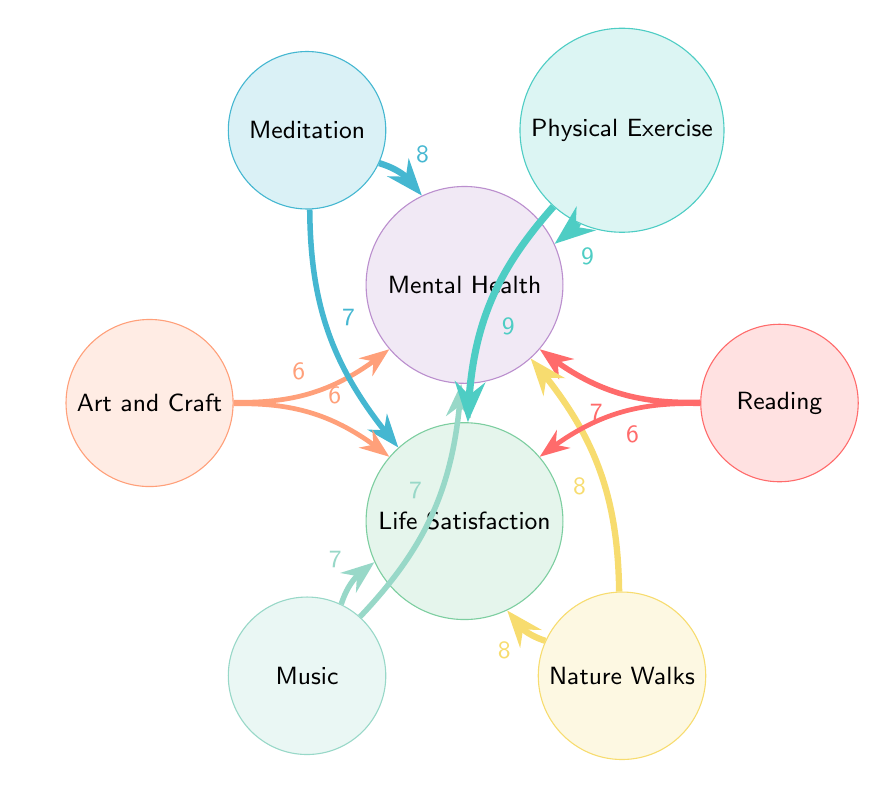What is the value from Physical Exercise to Mental Health? The diagram shows a directed link from Physical Exercise to Mental Health with a value of 9. This value indicates the level of influence Physical Exercise has on improving Mental Health.
Answer: 9 Which hobby has the lowest influence on Mental Health? To find this, we compare the values of all links to Mental Health. The values are 7 (Reading), 9 (Physical Exercise), 8 (Meditation), 6 (Art and Craft), 7 (Music), and 8 (Nature Walks). The lowest value among these is 6, coming from Art and Craft.
Answer: Art and Craft What is the strongest influence on Life Satisfaction? By examining the values leading to Life Satisfaction, we identify them as 6 (Reading), 9 (Physical Exercise), 7 (Meditation), 6 (Art and Craft), 7 (Music), and 8 (Nature Walks). The highest value is 9 from Physical Exercise, indicating its strongest positive impact on Life Satisfaction.
Answer: Physical Exercise How many total links are there in the diagram? The total number of links is obtained by counting each directed relationship between hobbies and the two outcomes, Mental Health and Life Satisfaction. There are 12 links listed in total.
Answer: 12 Which two hobbies have the same influence on Life Satisfaction? The analysis of the links to Life Satisfaction shows the values: 6 (Reading), 9 (Physical Exercise), 7 (Meditation), 6 (Art and Craft), 7 (Music), and 8 (Nature Walks). The values of 7 come from both Meditation and Music, indicating that both hobbies have the same influence on Life Satisfaction.
Answer: Meditation and Music From which hobby does Meditation lead to Mental Health? The diagram indicates a direct link from Meditation to Mental Health with a value of 8, indicating a significant positive influence of Meditation on enhancing Mental Health.
Answer: 8 Which hobby influences both Mental Health and Life Satisfaction? Looking at the links, we find that all hobbies influence both aspects, but we need to see if there are any shared values. Several hobbies do influence both, but specifically, Physical Exercise has the highest values for both (9 to Mental Health and 9 to Life Satisfaction).
Answer: Physical Exercise 